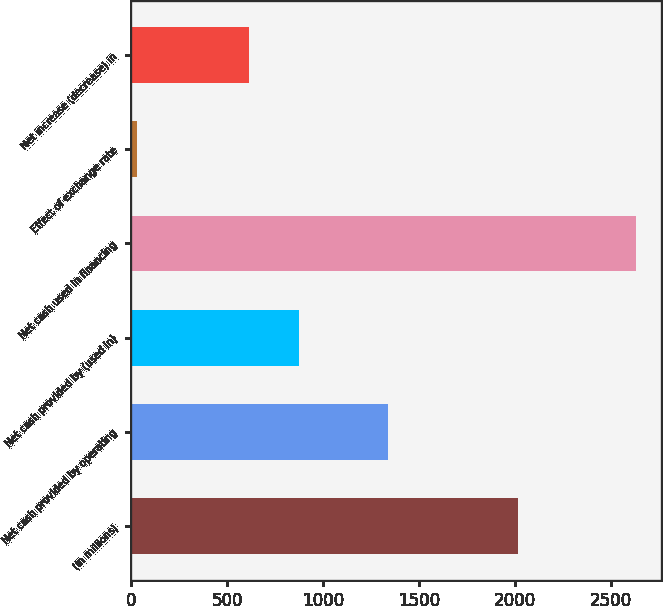<chart> <loc_0><loc_0><loc_500><loc_500><bar_chart><fcel>(In millions)<fcel>Net cash provided by operating<fcel>Net cash provided by (used in)<fcel>Net cash used in financing<fcel>Effect of exchange rate<fcel>Net increase (decrease) in<nl><fcel>2019<fcel>1341<fcel>876.1<fcel>2631<fcel>30<fcel>616<nl></chart> 